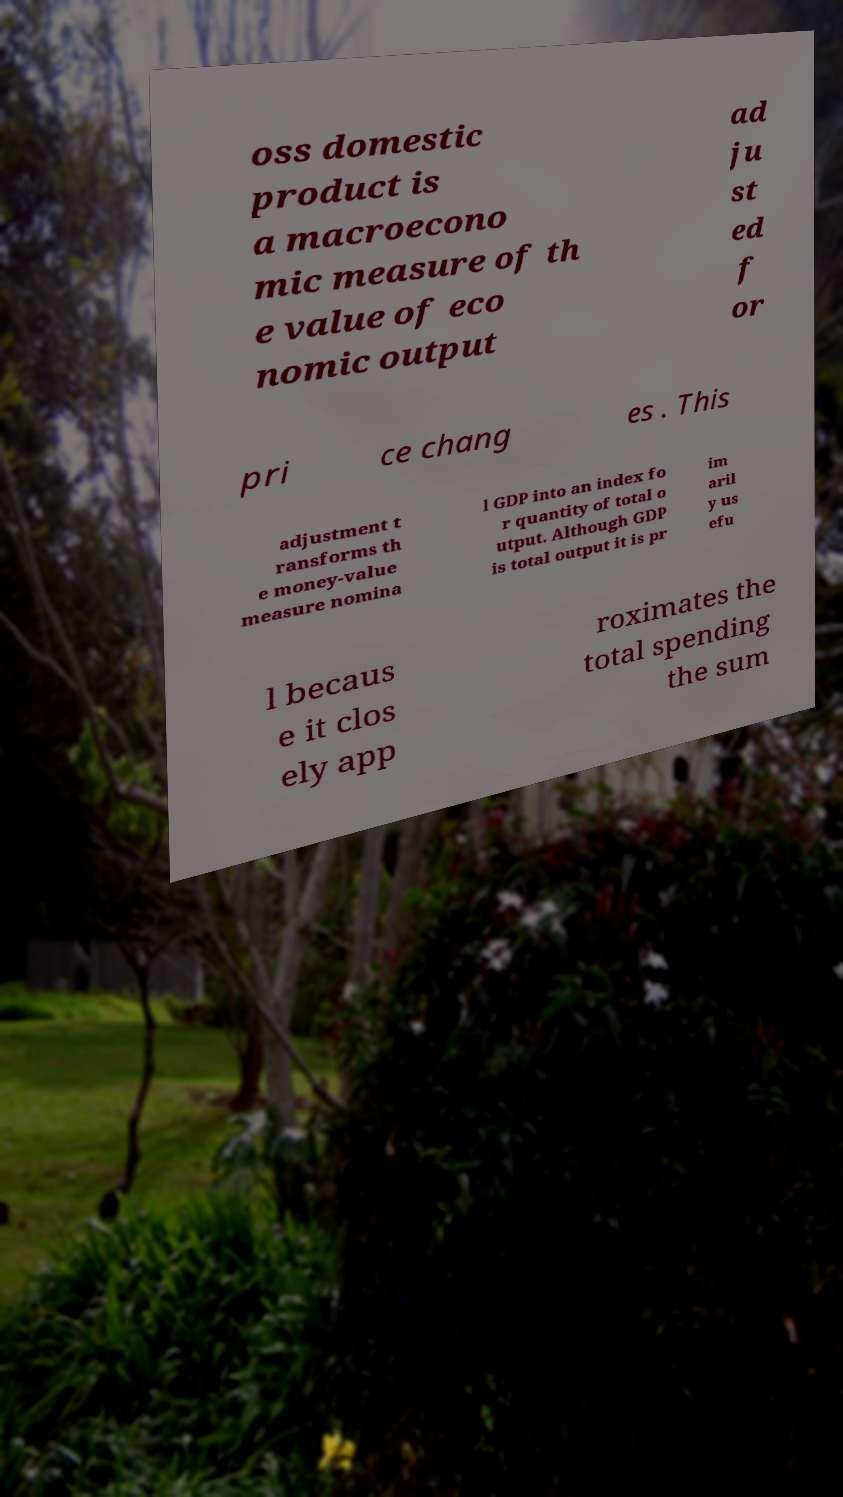For documentation purposes, I need the text within this image transcribed. Could you provide that? oss domestic product is a macroecono mic measure of th e value of eco nomic output ad ju st ed f or pri ce chang es . This adjustment t ransforms th e money-value measure nomina l GDP into an index fo r quantity of total o utput. Although GDP is total output it is pr im aril y us efu l becaus e it clos ely app roximates the total spending the sum 